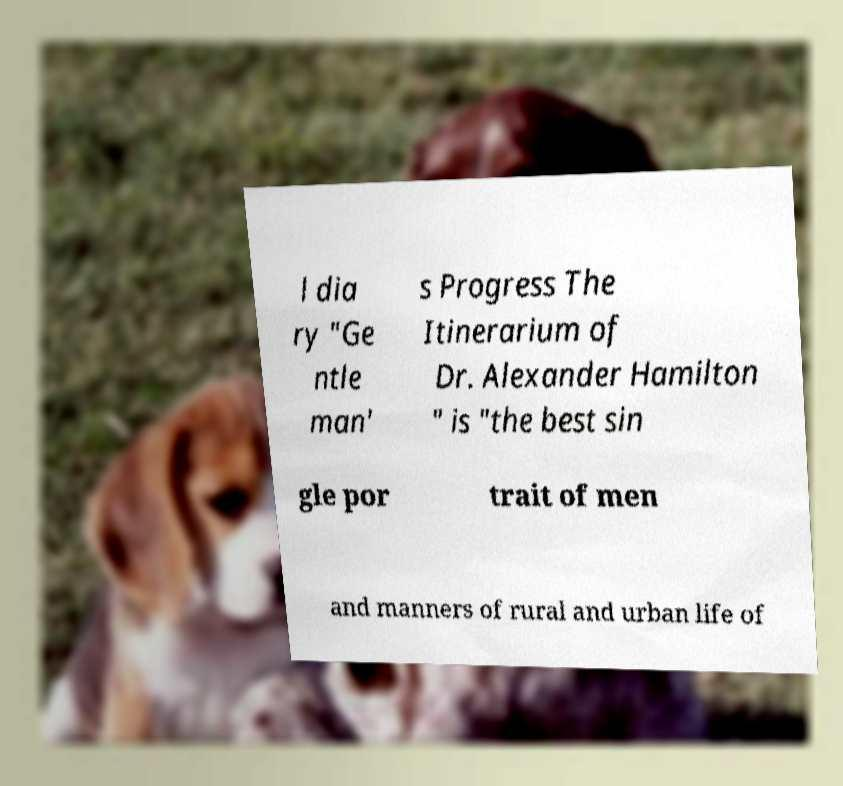Please read and relay the text visible in this image. What does it say? l dia ry "Ge ntle man' s Progress The Itinerarium of Dr. Alexander Hamilton " is "the best sin gle por trait of men and manners of rural and urban life of 